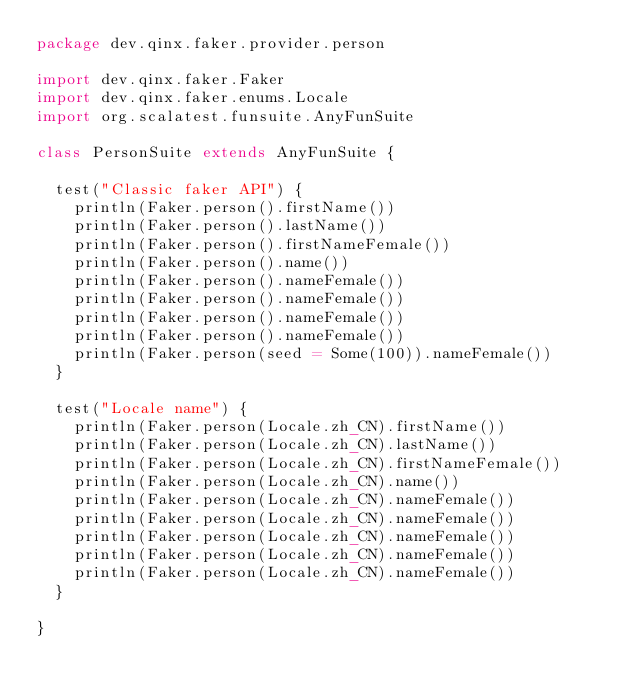Convert code to text. <code><loc_0><loc_0><loc_500><loc_500><_Scala_>package dev.qinx.faker.provider.person

import dev.qinx.faker.Faker
import dev.qinx.faker.enums.Locale
import org.scalatest.funsuite.AnyFunSuite

class PersonSuite extends AnyFunSuite {

  test("Classic faker API") {
    println(Faker.person().firstName())
    println(Faker.person().lastName())
    println(Faker.person().firstNameFemale())
    println(Faker.person().name())
    println(Faker.person().nameFemale())
    println(Faker.person().nameFemale())
    println(Faker.person().nameFemale())
    println(Faker.person().nameFemale())
    println(Faker.person(seed = Some(100)).nameFemale())
  }

  test("Locale name") {
    println(Faker.person(Locale.zh_CN).firstName())
    println(Faker.person(Locale.zh_CN).lastName())
    println(Faker.person(Locale.zh_CN).firstNameFemale())
    println(Faker.person(Locale.zh_CN).name())
    println(Faker.person(Locale.zh_CN).nameFemale())
    println(Faker.person(Locale.zh_CN).nameFemale())
    println(Faker.person(Locale.zh_CN).nameFemale())
    println(Faker.person(Locale.zh_CN).nameFemale())
    println(Faker.person(Locale.zh_CN).nameFemale())
  }

}
</code> 